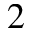Convert formula to latex. <formula><loc_0><loc_0><loc_500><loc_500>^ { 2 }</formula> 